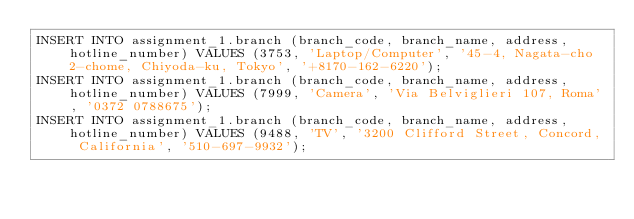<code> <loc_0><loc_0><loc_500><loc_500><_SQL_>INSERT INTO assignment_1.branch (branch_code, branch_name, address, hotline_number) VALUES (3753, 'Laptop/Computer', '45-4, Nagata-cho 2-chome, Chiyoda-ku, Tokyo', '+8170-162-6220');
INSERT INTO assignment_1.branch (branch_code, branch_name, address, hotline_number) VALUES (7999, 'Camera', 'Via Belviglieri 107, Roma', '0372 0788675');
INSERT INTO assignment_1.branch (branch_code, branch_name, address, hotline_number) VALUES (9488, 'TV', '3200 Clifford Street, Concord, California', '510-697-9932');</code> 